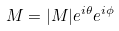Convert formula to latex. <formula><loc_0><loc_0><loc_500><loc_500>M = | M | e ^ { i \theta } e ^ { i \phi }</formula> 